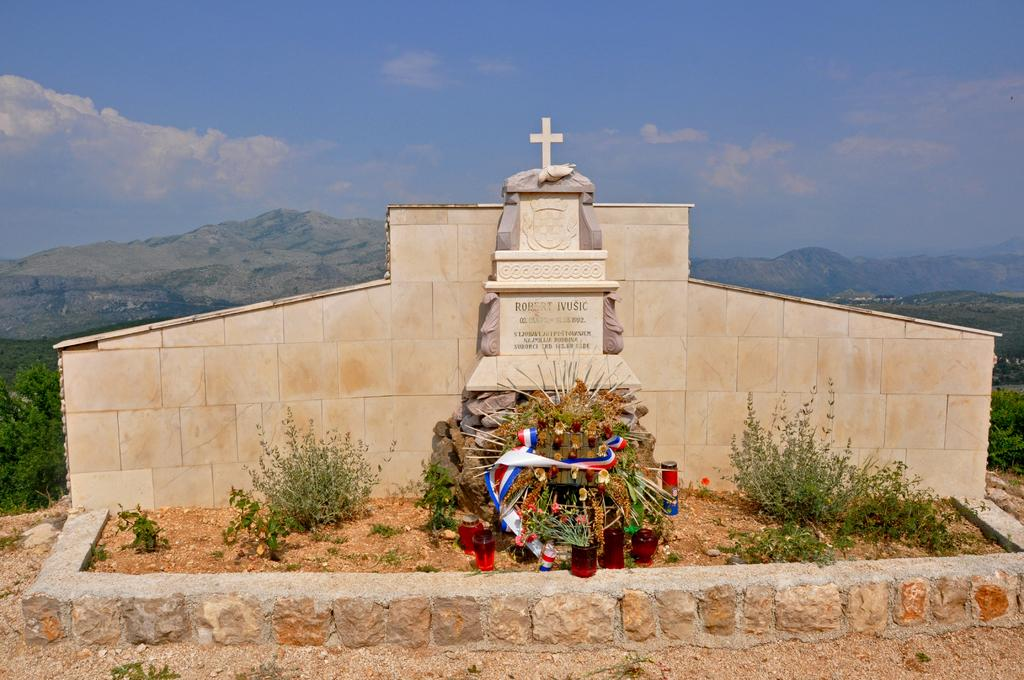What type of location is depicted in the image? There is a cemetery in the image. What can be seen on either side of the cemetery? There are plants on either side of the cemetery. What is located behind the cemetery? The cemetery is in front of a wall. What is visible in the background of the image? Hills are visible in the background of the image. What is visible in the sky in the image? The sky is visible in the image, and clouds are present. What type of pies are being sold in the alley next to the cemetery? There is no alley or pies present in the image; it only features a cemetery, plants, a wall, hills, and the sky. 